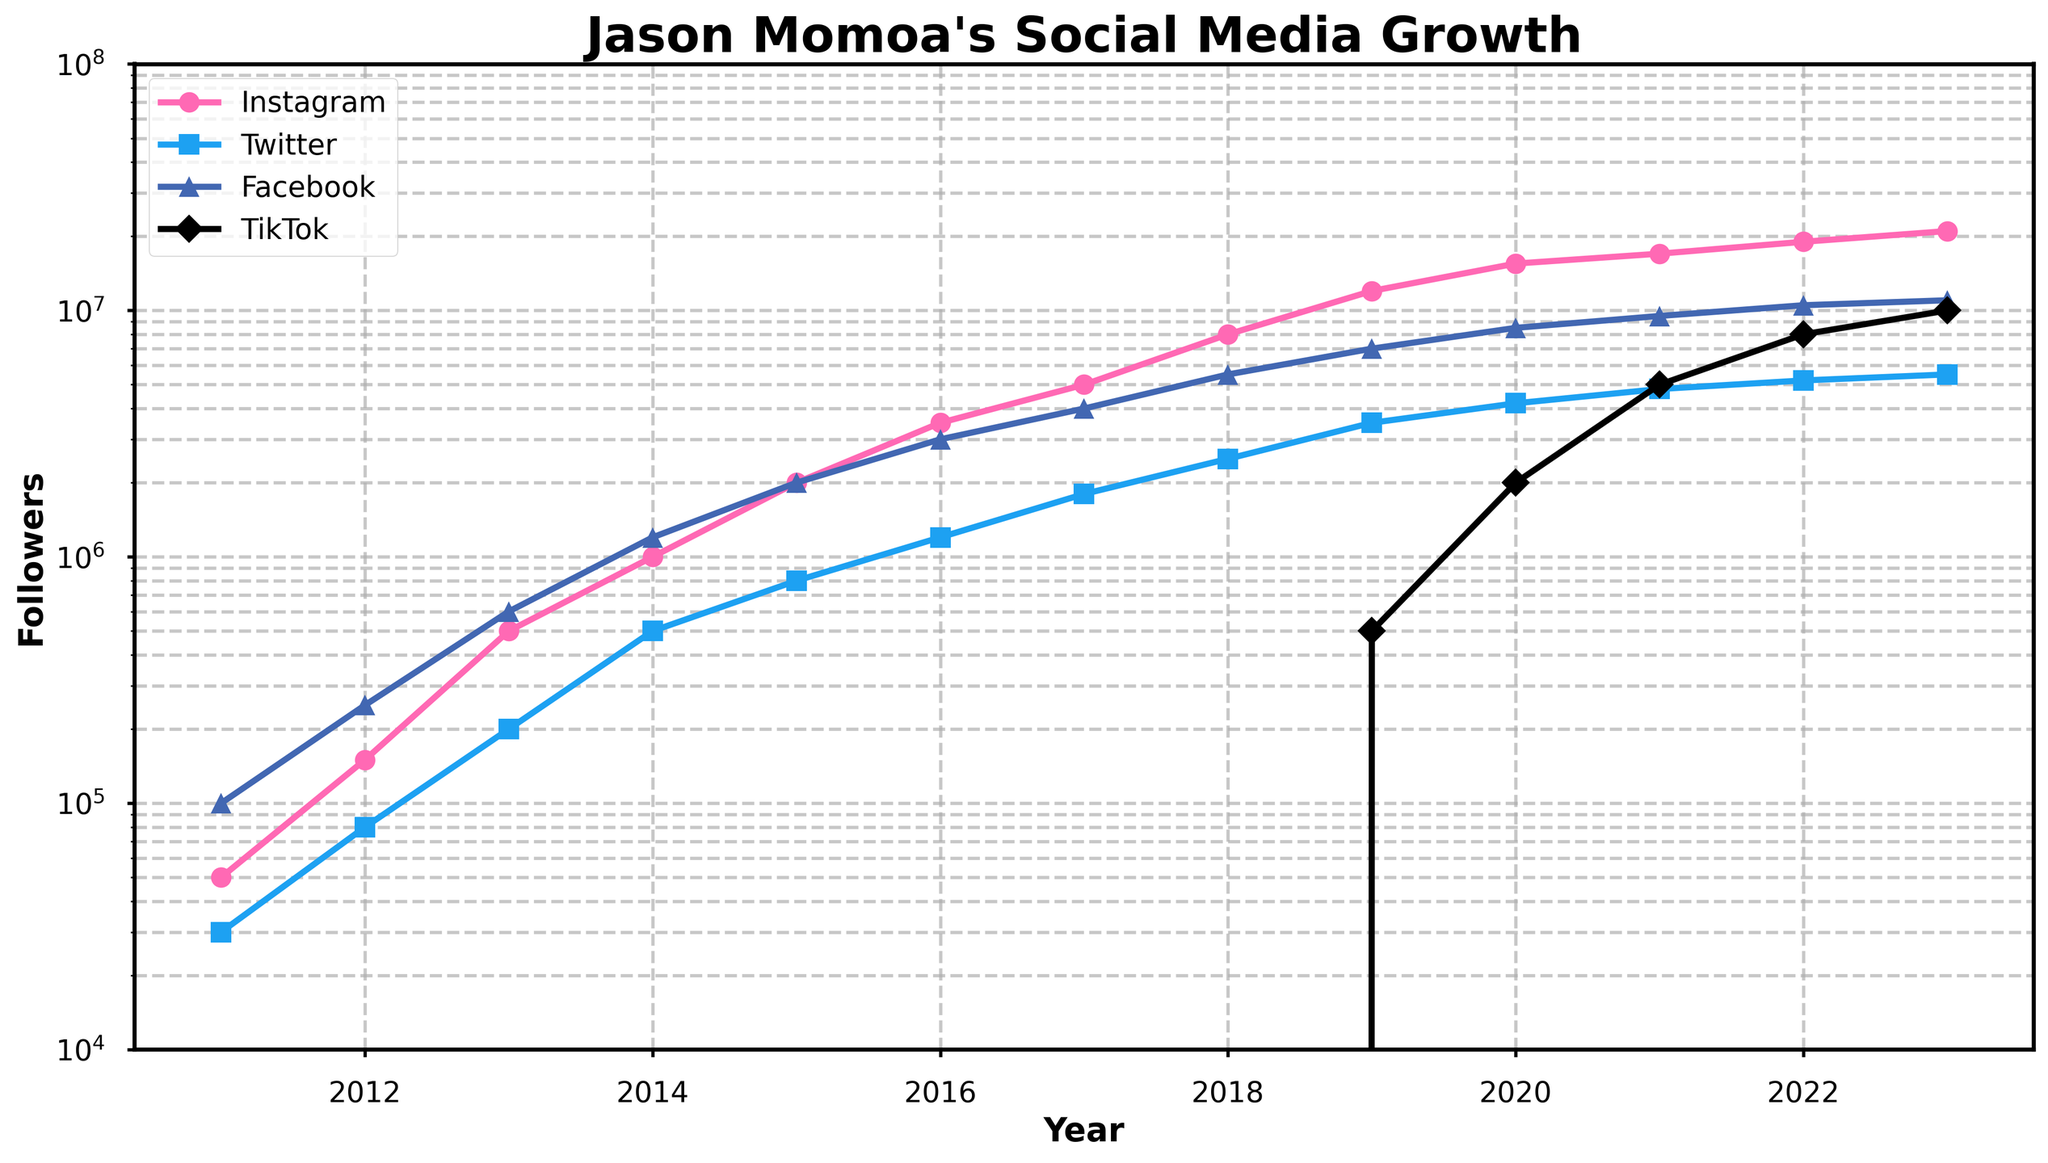Which platform saw the highest follower growth between 2018 and 2023? Compare the follower counts for each platform in 2018 and 2023. Instagram goes from 8M to 21M; Twitter from 2.5M to 5.5M; Facebook from 5.5M to 11M; TikTok from 0 to 10M. Instagram has the highest growth of 13M.
Answer: Instagram Which year did TikTok first start to have followers for Jason Momoa? Look at the TikTok line and find the first non-zero data point. TikTok first shows followers in 2019.
Answer: 2019 By how many millions of followers did Jason Momoa's Instagram followers increase from 2011 to 2023? Subtract the 2011 Instagram followers from the 2023 Instagram followers. 21M - 0.05M = 20.95M.
Answer: 20.95M How did the follower counts on Twitter and Facebook in 2016 compare? Look at the data points for Twitter and Facebook in 2016. Twitter had 1.2M and Facebook had 3M. Facebook had more followers.
Answer: Facebook had more Which platform saw the highest follower count in 2020? Look at the follower counts for each platform in 2020. Instagram had 15.5M, Twitter had 4.2M, Facebook had 8.5M, TikTok had 2M. Instagram had the highest follower count.
Answer: Instagram In which year did Jason Momoa’s Instagram followers reach 5 million? Identify the year when the Instagram line reaches 5M. This occurs in 2017.
Answer: 2017 Which platform had the slowest growth rate between 2012 and 2019? Compare the difference in follower counts for each platform between 2012 and 2019. Instagram: 11.85M, Twitter: 2.7M, Facebook: 6.75M, TikTok: 0.5M. TikTok has the slowest growth rate because it starts from 0 in 2019.
Answer: TikTok What was the combined total of Jason Momoa’s followers across all platforms in 2021? Sum the follower counts from Instagram, Twitter, Facebook, and TikTok for 2021. 17M + 4.8M + 9.5M + 5M = 36.3M.
Answer: 36.3M How does the log scale help interpret the follower growth on this chart? The log scale makes it easier to observe both significant and minor growth trends on the same chart, especially when the data spans multiple orders of magnitude. This allows for a more nuanced comparison of follower growth across different platforms over time.
Answer: Provides detailed view During which years did Jason Momoa's Facebook followers surpass 8 million? Observe the Facebook line and identify the years it surpasses 8M. This occurs from 2020 onwards.
Answer: 2020 onwards 